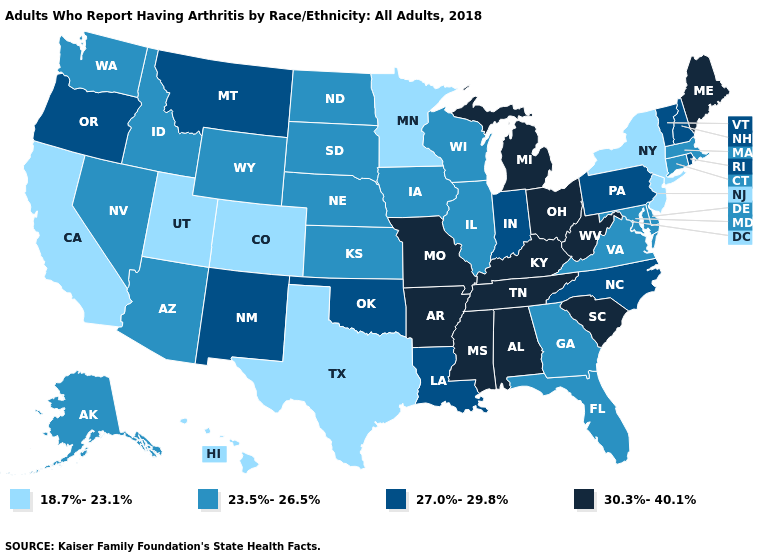How many symbols are there in the legend?
Keep it brief. 4. Does Nevada have a higher value than California?
Be succinct. Yes. Name the states that have a value in the range 23.5%-26.5%?
Give a very brief answer. Alaska, Arizona, Connecticut, Delaware, Florida, Georgia, Idaho, Illinois, Iowa, Kansas, Maryland, Massachusetts, Nebraska, Nevada, North Dakota, South Dakota, Virginia, Washington, Wisconsin, Wyoming. Name the states that have a value in the range 23.5%-26.5%?
Write a very short answer. Alaska, Arizona, Connecticut, Delaware, Florida, Georgia, Idaho, Illinois, Iowa, Kansas, Maryland, Massachusetts, Nebraska, Nevada, North Dakota, South Dakota, Virginia, Washington, Wisconsin, Wyoming. Does the map have missing data?
Answer briefly. No. What is the value of Oklahoma?
Answer briefly. 27.0%-29.8%. What is the highest value in states that border Washington?
Quick response, please. 27.0%-29.8%. How many symbols are there in the legend?
Give a very brief answer. 4. Name the states that have a value in the range 23.5%-26.5%?
Be succinct. Alaska, Arizona, Connecticut, Delaware, Florida, Georgia, Idaho, Illinois, Iowa, Kansas, Maryland, Massachusetts, Nebraska, Nevada, North Dakota, South Dakota, Virginia, Washington, Wisconsin, Wyoming. Which states have the lowest value in the USA?
Be succinct. California, Colorado, Hawaii, Minnesota, New Jersey, New York, Texas, Utah. Does the first symbol in the legend represent the smallest category?
Short answer required. Yes. What is the value of South Dakota?
Write a very short answer. 23.5%-26.5%. What is the lowest value in states that border Oregon?
Be succinct. 18.7%-23.1%. What is the lowest value in the South?
Write a very short answer. 18.7%-23.1%. What is the lowest value in the USA?
Concise answer only. 18.7%-23.1%. 